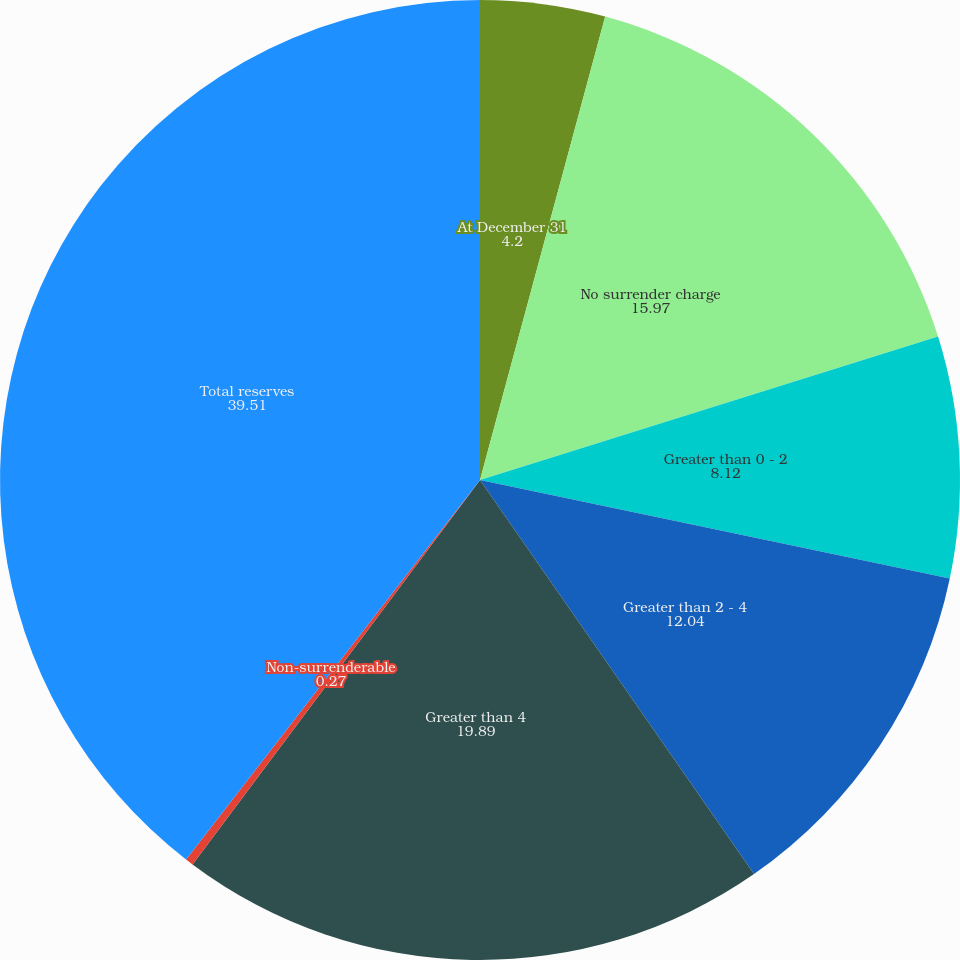Convert chart to OTSL. <chart><loc_0><loc_0><loc_500><loc_500><pie_chart><fcel>At December 31<fcel>No surrender charge<fcel>Greater than 0 - 2<fcel>Greater than 2 - 4<fcel>Greater than 4<fcel>Non-surrenderable<fcel>Total reserves<nl><fcel>4.2%<fcel>15.97%<fcel>8.12%<fcel>12.04%<fcel>19.89%<fcel>0.27%<fcel>39.51%<nl></chart> 